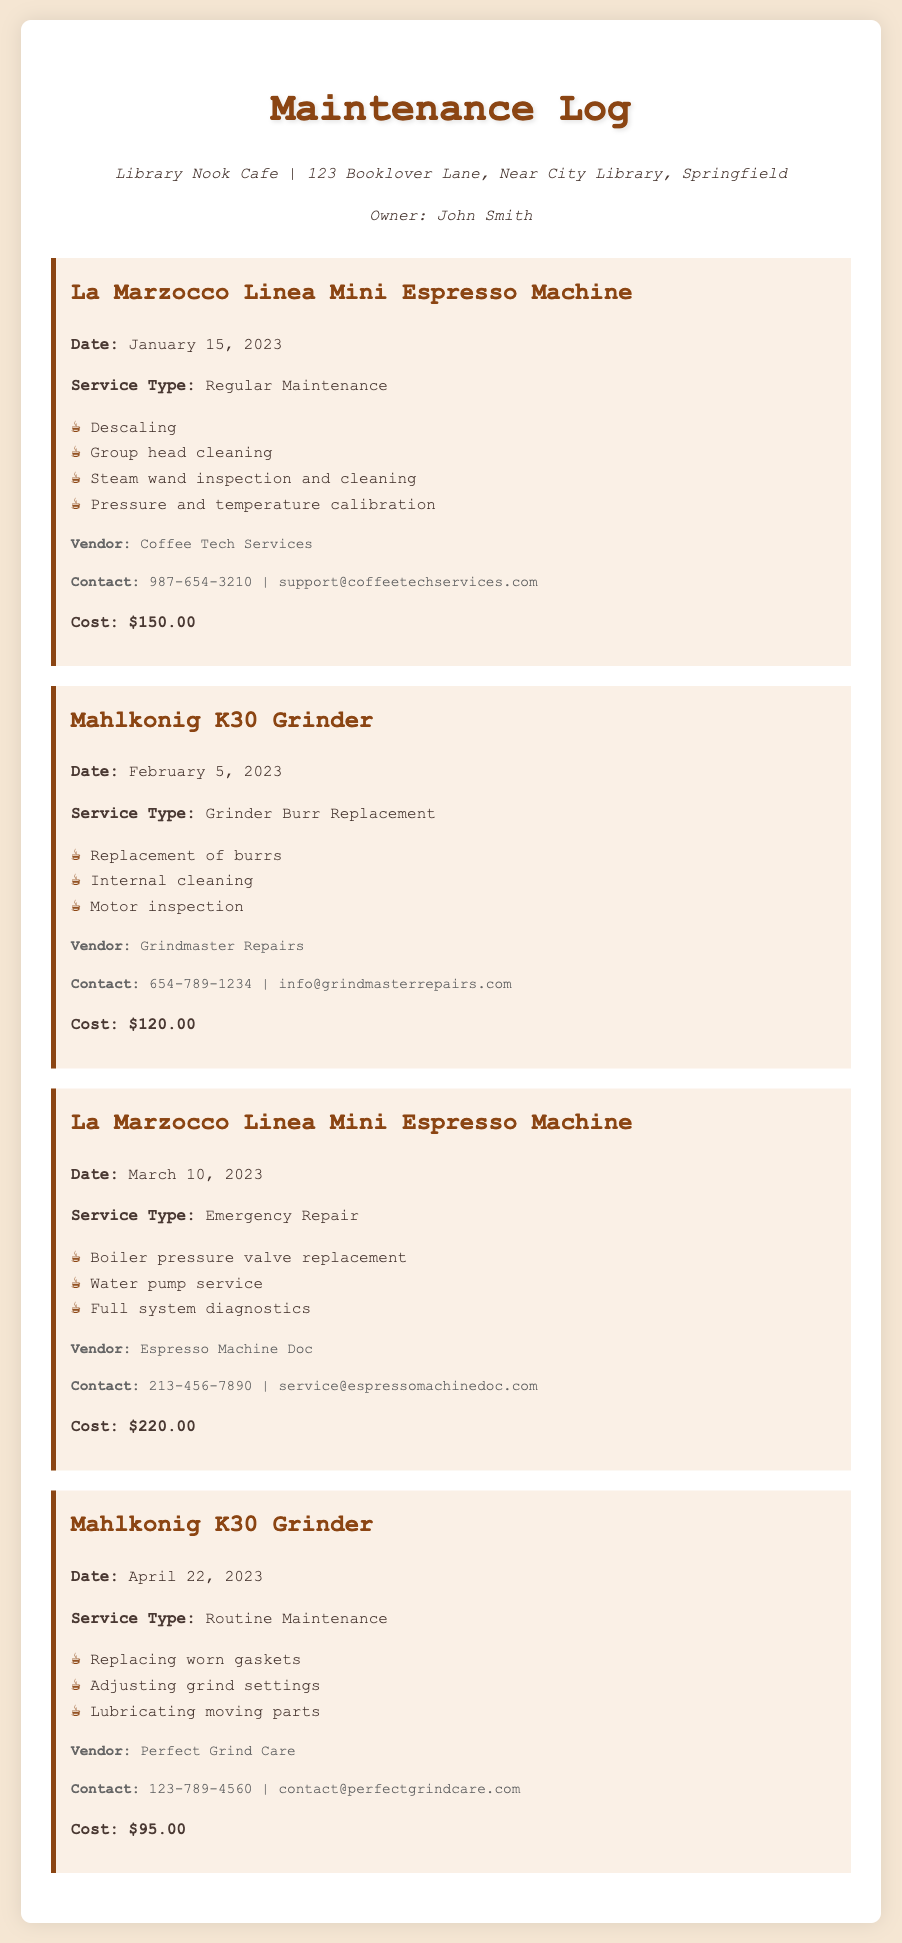What is the vendor for the La Marzocco Linea Mini Espresso Machine? The vendor listed for the La Marzocco Linea Mini Espresso Machine is Coffee Tech Services for the first entry and Espresso Machine Doc for the emergency repair.
Answer: Coffee Tech Services What was the cost of the grinder burr replacement service? The document states that the cost for the Mahlkonig K30 Grinder's burr replacement service was $120.00.
Answer: $120.00 When was the routine maintenance performed on the Mahlkonig K30 Grinder? The log entry specifies that the routine maintenance for the Mahlkonig K30 Grinder was performed on April 22, 2023.
Answer: April 22, 2023 How many tasks were performed during the emergency repair of the La Marzocco Linea Mini Espresso Machine? The entry for the emergency repair indicates there were three tasks performed.
Answer: Three What type of service was conducted on January 15, 2023? The document specifies that regular maintenance was performed on the La Marzocco Linea Mini Espresso Machine on this date.
Answer: Regular Maintenance Which vendor conducted the routine maintenance for the Mahlkonig K30 Grinder? The vendor for the routine maintenance on the Mahlkonig K30 Grinder is Perfect Grind Care.
Answer: Perfect Grind Care What was replaced during the emergency repair on the La Marzocco Linea Mini Espresso Machine? One of the tasks during the emergency repair was the replacement of the boiler pressure valve.
Answer: Boiler pressure valve What type of inspection was performed on the Mahlkonig K30 Grinder in the February service? The February service included a motor inspection as part of the grinder burr replacement.
Answer: Motor inspection What is the contact email for Espresso Machine Doc? The log provides the contact email for Espresso Machine Doc as service@espressomachinedoc.com.
Answer: service@espressomachinedoc.com 